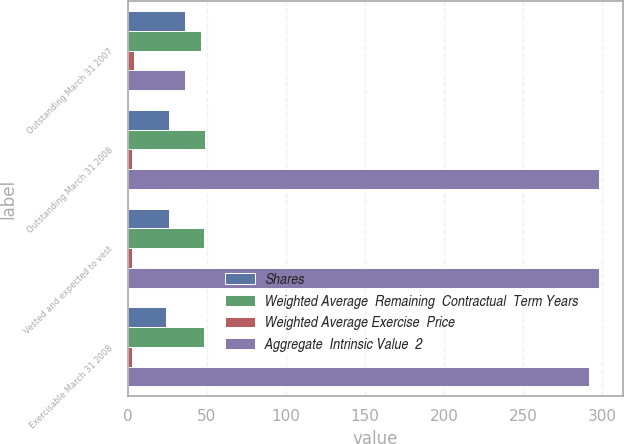Convert chart. <chart><loc_0><loc_0><loc_500><loc_500><stacked_bar_chart><ecel><fcel>Outstanding March 31 2007<fcel>Outstanding March 31 2008<fcel>Vested and expected to vest<fcel>Exercisable March 31 2008<nl><fcel>Shares<fcel>36<fcel>26<fcel>26<fcel>24<nl><fcel>Weighted Average  Remaining  Contractual  Term Years<fcel>46.32<fcel>48.59<fcel>48.27<fcel>48.1<nl><fcel>Weighted Average Exercise  Price<fcel>4<fcel>3<fcel>3<fcel>3<nl><fcel>Aggregate  Intrinsic Value  2<fcel>36<fcel>298<fcel>298<fcel>292<nl></chart> 